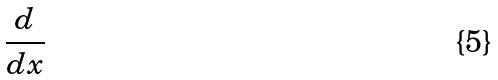<formula> <loc_0><loc_0><loc_500><loc_500>\frac { d } { d x }</formula> 